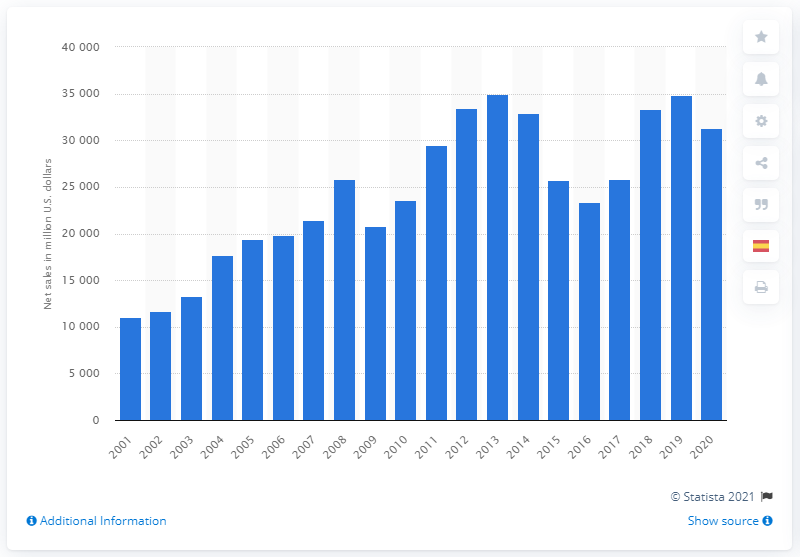Draw attention to some important aspects in this diagram. In 2016, John Deere's net sales were 23,387. In 2016, John Deere's net income was 23,387. 